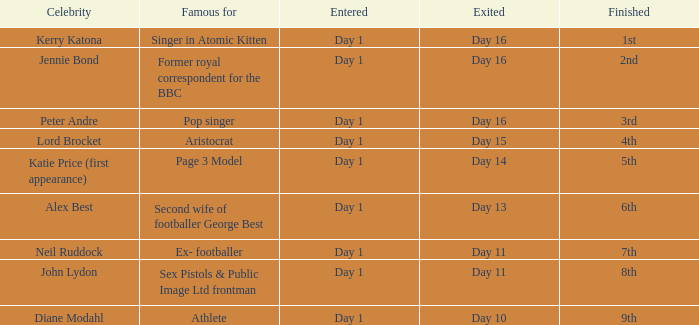Could you parse the entire table? {'header': ['Celebrity', 'Famous for', 'Entered', 'Exited', 'Finished'], 'rows': [['Kerry Katona', 'Singer in Atomic Kitten', 'Day 1', 'Day 16', '1st'], ['Jennie Bond', 'Former royal correspondent for the BBC', 'Day 1', 'Day 16', '2nd'], ['Peter Andre', 'Pop singer', 'Day 1', 'Day 16', '3rd'], ['Lord Brocket', 'Aristocrat', 'Day 1', 'Day 15', '4th'], ['Katie Price (first appearance)', 'Page 3 Model', 'Day 1', 'Day 14', '5th'], ['Alex Best', 'Second wife of footballer George Best', 'Day 1', 'Day 13', '6th'], ['Neil Ruddock', 'Ex- footballer', 'Day 1', 'Day 11', '7th'], ['John Lydon', 'Sex Pistols & Public Image Ltd frontman', 'Day 1', 'Day 11', '8th'], ['Diane Modahl', 'Athlete', 'Day 1', 'Day 10', '9th']]} Identify the finalized outcome for the departed day 13. 6th. 